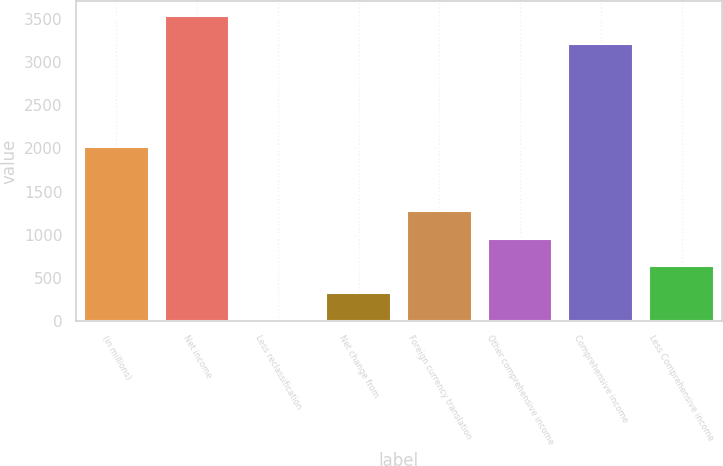Convert chart to OTSL. <chart><loc_0><loc_0><loc_500><loc_500><bar_chart><fcel>(in millions)<fcel>Net income<fcel>Less reclassification<fcel>Net change from<fcel>Foreign currency translation<fcel>Other comprehensive income<fcel>Comprehensive income<fcel>Less Comprehensive income<nl><fcel>2016<fcel>3535.8<fcel>1<fcel>317.9<fcel>1268.6<fcel>951.7<fcel>3218.9<fcel>634.8<nl></chart> 